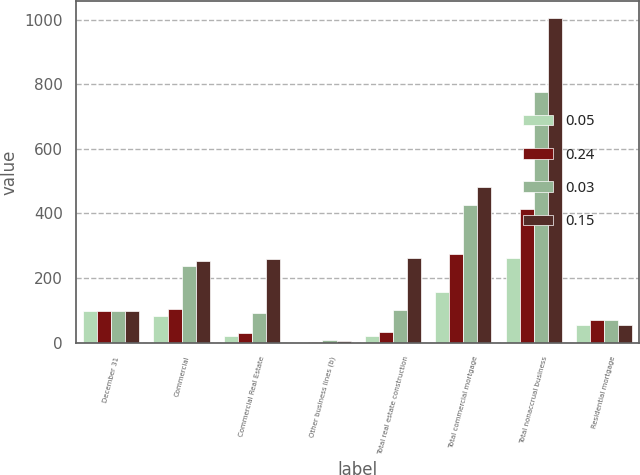Convert chart to OTSL. <chart><loc_0><loc_0><loc_500><loc_500><stacked_bar_chart><ecel><fcel>December 31<fcel>Commercial<fcel>Commercial Real Estate<fcel>Other business lines (b)<fcel>Total real estate construction<fcel>Total commercial mortgage<fcel>Total nonaccrual business<fcel>Residential mortgage<nl><fcel>0.05<fcel>97<fcel>81<fcel>20<fcel>1<fcel>21<fcel>156<fcel>262<fcel>53<nl><fcel>0.24<fcel>97<fcel>103<fcel>30<fcel>3<fcel>33<fcel>275<fcel>414<fcel>70<nl><fcel>0.03<fcel>97<fcel>237<fcel>93<fcel>8<fcel>101<fcel>427<fcel>778<fcel>71<nl><fcel>0.15<fcel>97<fcel>252<fcel>259<fcel>4<fcel>263<fcel>483<fcel>1007<fcel>55<nl></chart> 